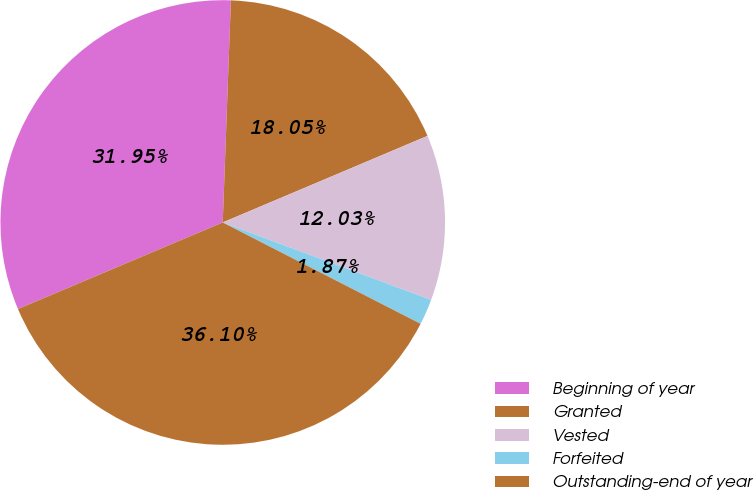<chart> <loc_0><loc_0><loc_500><loc_500><pie_chart><fcel>Beginning of year<fcel>Granted<fcel>Vested<fcel>Forfeited<fcel>Outstanding-end of year<nl><fcel>31.95%<fcel>18.05%<fcel>12.03%<fcel>1.87%<fcel>36.1%<nl></chart> 